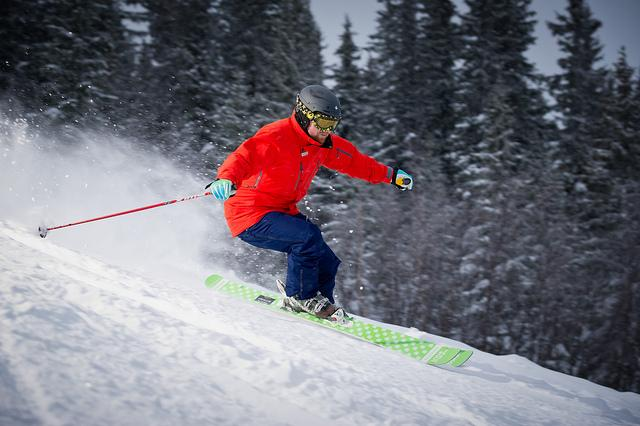What color is the snow jacket worn by the skier?

Choices:
A) green
B) blue
C) orange
D) yellow orange 